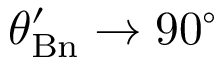<formula> <loc_0><loc_0><loc_500><loc_500>\theta _ { B n } ^ { \prime } \rightarrow 9 0 ^ { \circ }</formula> 